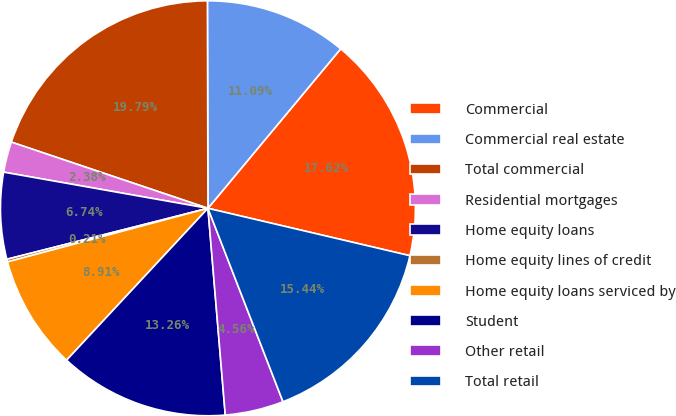Convert chart to OTSL. <chart><loc_0><loc_0><loc_500><loc_500><pie_chart><fcel>Commercial<fcel>Commercial real estate<fcel>Total commercial<fcel>Residential mortgages<fcel>Home equity loans<fcel>Home equity lines of credit<fcel>Home equity loans serviced by<fcel>Student<fcel>Other retail<fcel>Total retail<nl><fcel>17.62%<fcel>11.09%<fcel>19.79%<fcel>2.38%<fcel>6.74%<fcel>0.21%<fcel>8.91%<fcel>13.26%<fcel>4.56%<fcel>15.44%<nl></chart> 